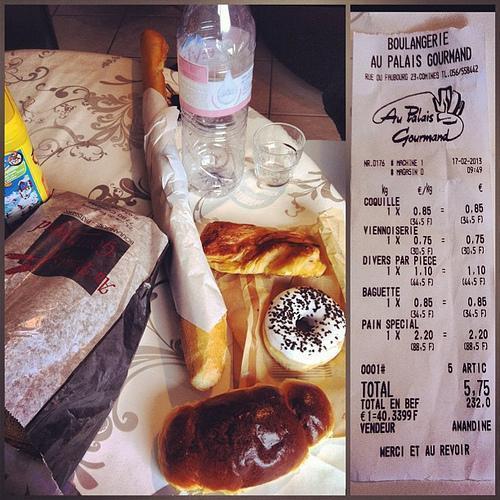How many food items are pictured?
Give a very brief answer. 4. How many donuts are pictures?
Give a very brief answer. 1. 